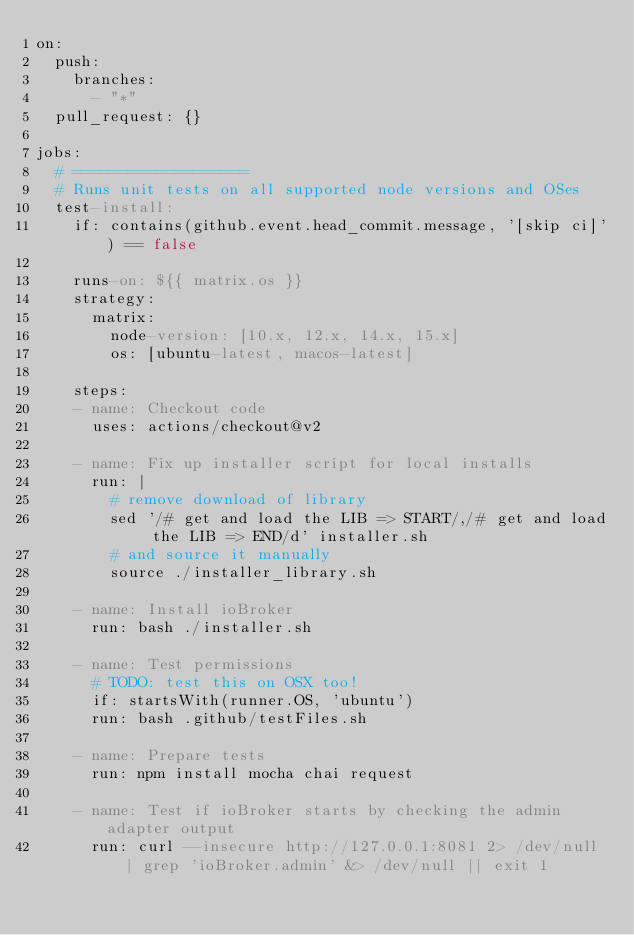Convert code to text. <code><loc_0><loc_0><loc_500><loc_500><_YAML_>on:
  push:
    branches:
      - "*"
  pull_request: {}

jobs:
  # ===================
  # Runs unit tests on all supported node versions and OSes
  test-install:
    if: contains(github.event.head_commit.message, '[skip ci]') == false

    runs-on: ${{ matrix.os }}
    strategy:
      matrix:
        node-version: [10.x, 12.x, 14.x, 15.x]
        os: [ubuntu-latest, macos-latest]

    steps:
    - name: Checkout code
      uses: actions/checkout@v2

    - name: Fix up installer script for local installs
      run: |
        # remove download of library
        sed '/# get and load the LIB => START/,/# get and load the LIB => END/d' installer.sh
        # and source it manually
        source ./installer_library.sh

    - name: Install ioBroker
      run: bash ./installer.sh

    - name: Test permissions
      # TODO: test this on OSX too!
      if: startsWith(runner.OS, 'ubuntu')
      run: bash .github/testFiles.sh

    - name: Prepare tests
      run: npm install mocha chai request

    - name: Test if ioBroker starts by checking the admin adapter output
      run: curl --insecure http://127.0.0.1:8081 2> /dev/null | grep 'ioBroker.admin' &> /dev/null || exit 1
</code> 